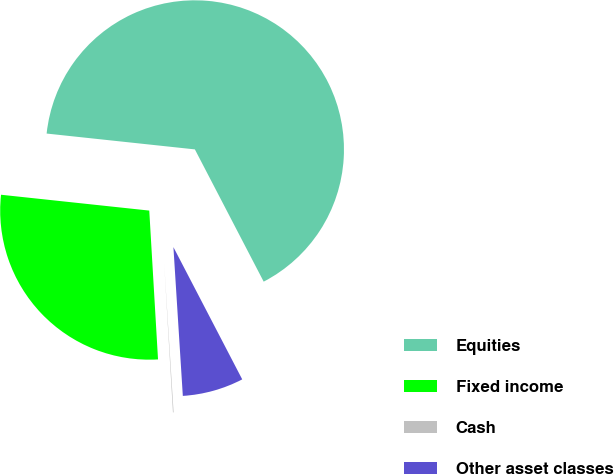Convert chart to OTSL. <chart><loc_0><loc_0><loc_500><loc_500><pie_chart><fcel>Equities<fcel>Fixed income<fcel>Cash<fcel>Other asset classes<nl><fcel>65.67%<fcel>27.63%<fcel>0.07%<fcel>6.63%<nl></chart> 